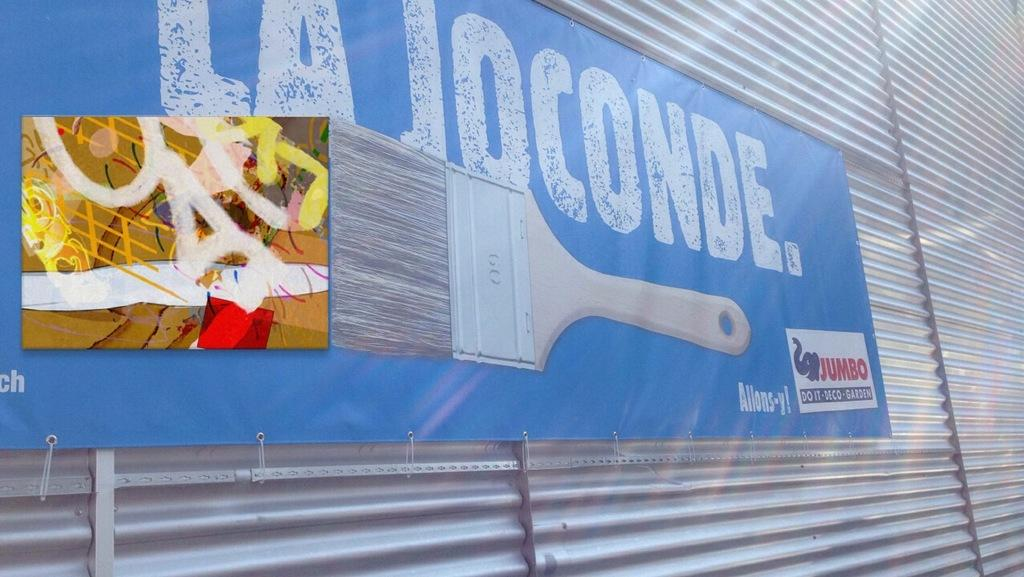What is the main object in the image? There is a board in the image. What is on the board? The board has text written on it. What is the board placed on? The board is on a metal sheet. How many dolls are sitting on the board in the image? There are no dolls present in the image; it only features a board with text on it. What type of liquid can be seen dripping from the board in the image? There is no liquid visible in the image; it only features a board with text on it. 